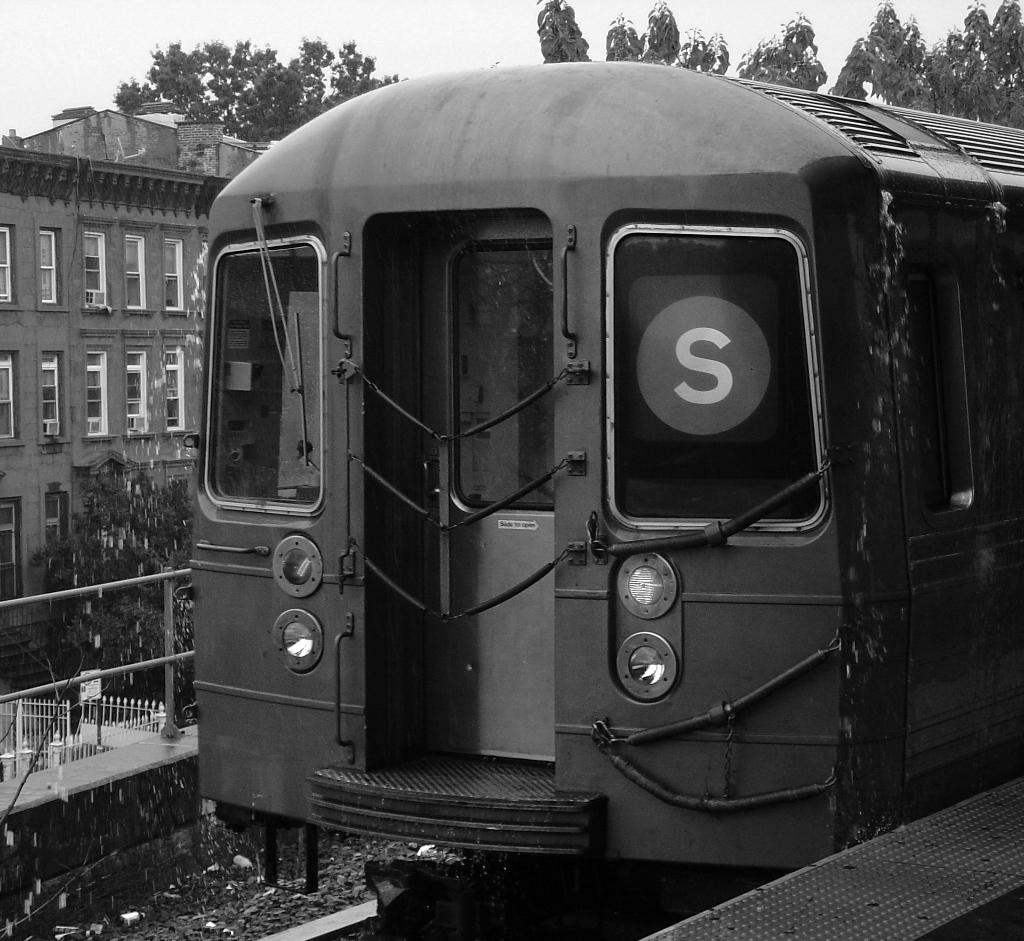What is the main subject of the image? The main subject of the image is a train. What can be seen alongside the train in the image? There is a railway track in the image. What other objects or structures are present in the image? There is a fence, trees, a building, and the sky is visible in the image. What type of skirt is the train wearing in the image? Trains do not wear skirts; they are vehicles and do not have clothing. 